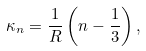Convert formula to latex. <formula><loc_0><loc_0><loc_500><loc_500>\kappa _ { n } = \frac { 1 } { R } \left ( n - \frac { 1 } { 3 } \right ) ,</formula> 